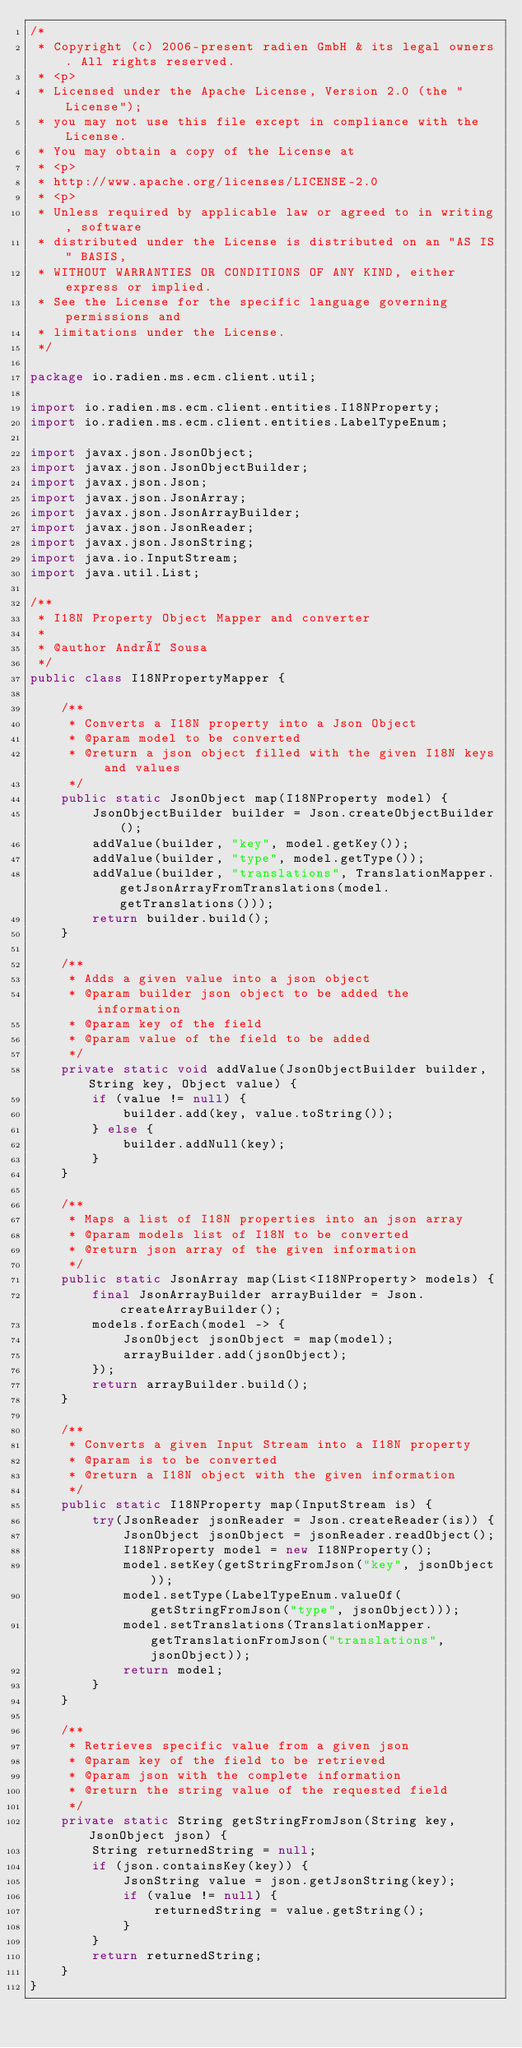<code> <loc_0><loc_0><loc_500><loc_500><_Java_>/*
 * Copyright (c) 2006-present radien GmbH & its legal owners. All rights reserved.
 * <p>
 * Licensed under the Apache License, Version 2.0 (the "License");
 * you may not use this file except in compliance with the License.
 * You may obtain a copy of the License at
 * <p>
 * http://www.apache.org/licenses/LICENSE-2.0
 * <p>
 * Unless required by applicable law or agreed to in writing, software
 * distributed under the License is distributed on an "AS IS" BASIS,
 * WITHOUT WARRANTIES OR CONDITIONS OF ANY KIND, either express or implied.
 * See the License for the specific language governing permissions and
 * limitations under the License.
 */

package io.radien.ms.ecm.client.util;

import io.radien.ms.ecm.client.entities.I18NProperty;
import io.radien.ms.ecm.client.entities.LabelTypeEnum;

import javax.json.JsonObject;
import javax.json.JsonObjectBuilder;
import javax.json.Json;
import javax.json.JsonArray;
import javax.json.JsonArrayBuilder;
import javax.json.JsonReader;
import javax.json.JsonString;
import java.io.InputStream;
import java.util.List;

/**
 * I18N Property Object Mapper and converter
 *
 * @author André Sousa
 */
public class I18NPropertyMapper {

    /**
     * Converts a I18N property into a Json Object
     * @param model to be converted
     * @return a json object filled with the given I18N keys and values
     */
    public static JsonObject map(I18NProperty model) {
        JsonObjectBuilder builder = Json.createObjectBuilder();
        addValue(builder, "key", model.getKey());
        addValue(builder, "type", model.getType());
        addValue(builder, "translations", TranslationMapper.getJsonArrayFromTranslations(model.getTranslations()));
        return builder.build();
    }

    /**
     * Adds a given value into a json object
     * @param builder json object to be added the information
     * @param key of the field
     * @param value of the field to be added
     */
    private static void addValue(JsonObjectBuilder builder, String key, Object value) {
        if (value != null) {
            builder.add(key, value.toString());
        } else {
            builder.addNull(key);
        }
    }

    /**
     * Maps a list of I18N properties into an json array
     * @param models list of I18N to be converted
     * @return json array of the given information
     */
    public static JsonArray map(List<I18NProperty> models) {
        final JsonArrayBuilder arrayBuilder = Json.createArrayBuilder();
        models.forEach(model -> {
            JsonObject jsonObject = map(model);
            arrayBuilder.add(jsonObject);
        });
        return arrayBuilder.build();
    }

    /**
     * Converts a given Input Stream into a I18N property
     * @param is to be converted
     * @return a I18N object with the given information
     */
    public static I18NProperty map(InputStream is) {
        try(JsonReader jsonReader = Json.createReader(is)) {
            JsonObject jsonObject = jsonReader.readObject();
            I18NProperty model = new I18NProperty();
            model.setKey(getStringFromJson("key", jsonObject));
            model.setType(LabelTypeEnum.valueOf(getStringFromJson("type", jsonObject)));
            model.setTranslations(TranslationMapper.getTranslationFromJson("translations", jsonObject));
            return model;
        }
    }

    /**
     * Retrieves specific value from a given json
     * @param key of the field to be retrieved
     * @param json with the complete information
     * @return the string value of the requested field
     */
    private static String getStringFromJson(String key, JsonObject json) {
        String returnedString = null;
        if (json.containsKey(key)) {
            JsonString value = json.getJsonString(key);
            if (value != null) {
                returnedString = value.getString();
            }
        }
        return returnedString;
    }
}
</code> 